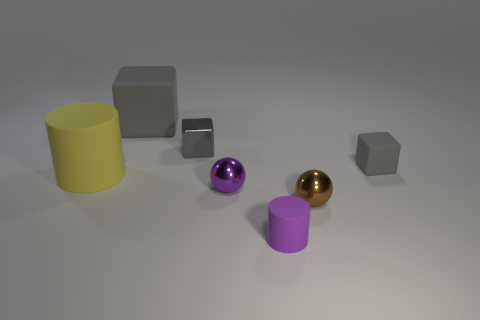Which object stands out the most to you and why? The golden ball stands out the most. It catches the eye due to its reflective surface that contrasts with the matte textures of the other objects, and its color also differs significantly from the rest, making it a focal point in the image. 